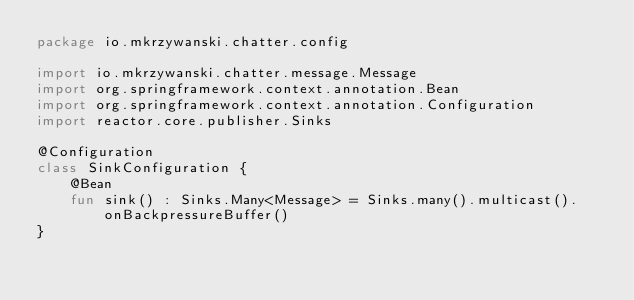Convert code to text. <code><loc_0><loc_0><loc_500><loc_500><_Kotlin_>package io.mkrzywanski.chatter.config

import io.mkrzywanski.chatter.message.Message
import org.springframework.context.annotation.Bean
import org.springframework.context.annotation.Configuration
import reactor.core.publisher.Sinks

@Configuration
class SinkConfiguration {
    @Bean
    fun sink() : Sinks.Many<Message> = Sinks.many().multicast().onBackpressureBuffer()
}</code> 